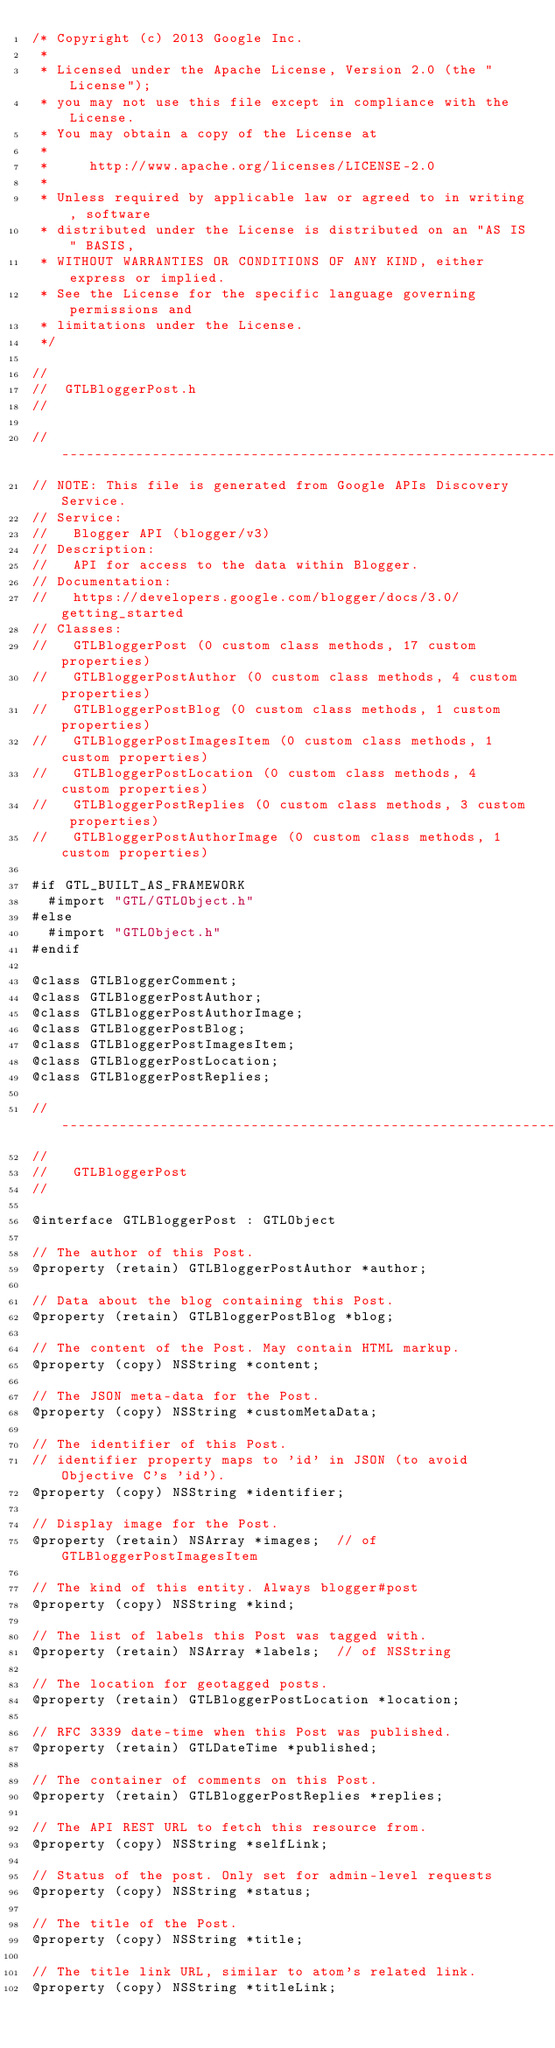Convert code to text. <code><loc_0><loc_0><loc_500><loc_500><_C_>/* Copyright (c) 2013 Google Inc.
 *
 * Licensed under the Apache License, Version 2.0 (the "License");
 * you may not use this file except in compliance with the License.
 * You may obtain a copy of the License at
 *
 *     http://www.apache.org/licenses/LICENSE-2.0
 *
 * Unless required by applicable law or agreed to in writing, software
 * distributed under the License is distributed on an "AS IS" BASIS,
 * WITHOUT WARRANTIES OR CONDITIONS OF ANY KIND, either express or implied.
 * See the License for the specific language governing permissions and
 * limitations under the License.
 */

//
//  GTLBloggerPost.h
//

// ----------------------------------------------------------------------------
// NOTE: This file is generated from Google APIs Discovery Service.
// Service:
//   Blogger API (blogger/v3)
// Description:
//   API for access to the data within Blogger.
// Documentation:
//   https://developers.google.com/blogger/docs/3.0/getting_started
// Classes:
//   GTLBloggerPost (0 custom class methods, 17 custom properties)
//   GTLBloggerPostAuthor (0 custom class methods, 4 custom properties)
//   GTLBloggerPostBlog (0 custom class methods, 1 custom properties)
//   GTLBloggerPostImagesItem (0 custom class methods, 1 custom properties)
//   GTLBloggerPostLocation (0 custom class methods, 4 custom properties)
//   GTLBloggerPostReplies (0 custom class methods, 3 custom properties)
//   GTLBloggerPostAuthorImage (0 custom class methods, 1 custom properties)

#if GTL_BUILT_AS_FRAMEWORK
  #import "GTL/GTLObject.h"
#else
  #import "GTLObject.h"
#endif

@class GTLBloggerComment;
@class GTLBloggerPostAuthor;
@class GTLBloggerPostAuthorImage;
@class GTLBloggerPostBlog;
@class GTLBloggerPostImagesItem;
@class GTLBloggerPostLocation;
@class GTLBloggerPostReplies;

// ----------------------------------------------------------------------------
//
//   GTLBloggerPost
//

@interface GTLBloggerPost : GTLObject

// The author of this Post.
@property (retain) GTLBloggerPostAuthor *author;

// Data about the blog containing this Post.
@property (retain) GTLBloggerPostBlog *blog;

// The content of the Post. May contain HTML markup.
@property (copy) NSString *content;

// The JSON meta-data for the Post.
@property (copy) NSString *customMetaData;

// The identifier of this Post.
// identifier property maps to 'id' in JSON (to avoid Objective C's 'id').
@property (copy) NSString *identifier;

// Display image for the Post.
@property (retain) NSArray *images;  // of GTLBloggerPostImagesItem

// The kind of this entity. Always blogger#post
@property (copy) NSString *kind;

// The list of labels this Post was tagged with.
@property (retain) NSArray *labels;  // of NSString

// The location for geotagged posts.
@property (retain) GTLBloggerPostLocation *location;

// RFC 3339 date-time when this Post was published.
@property (retain) GTLDateTime *published;

// The container of comments on this Post.
@property (retain) GTLBloggerPostReplies *replies;

// The API REST URL to fetch this resource from.
@property (copy) NSString *selfLink;

// Status of the post. Only set for admin-level requests
@property (copy) NSString *status;

// The title of the Post.
@property (copy) NSString *title;

// The title link URL, similar to atom's related link.
@property (copy) NSString *titleLink;
</code> 